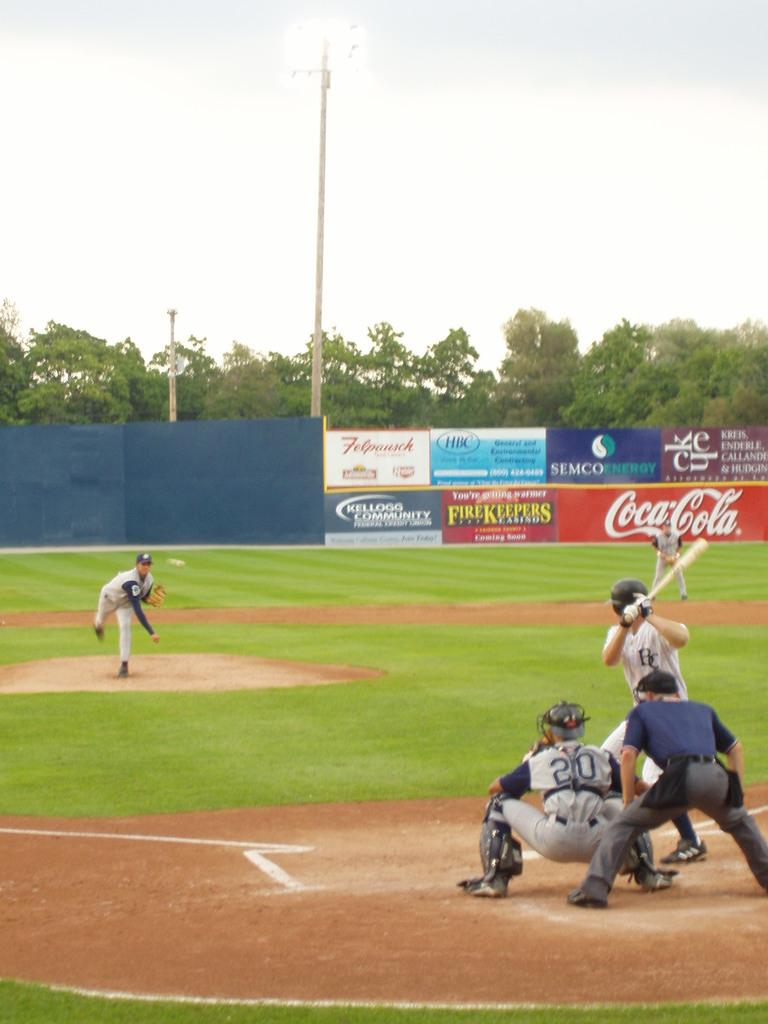<image>
Render a clear and concise summary of the photo. Pitcher pitching a baseball at a batter getting ready to swing at the ball, the catcher's jersey is # 20. 